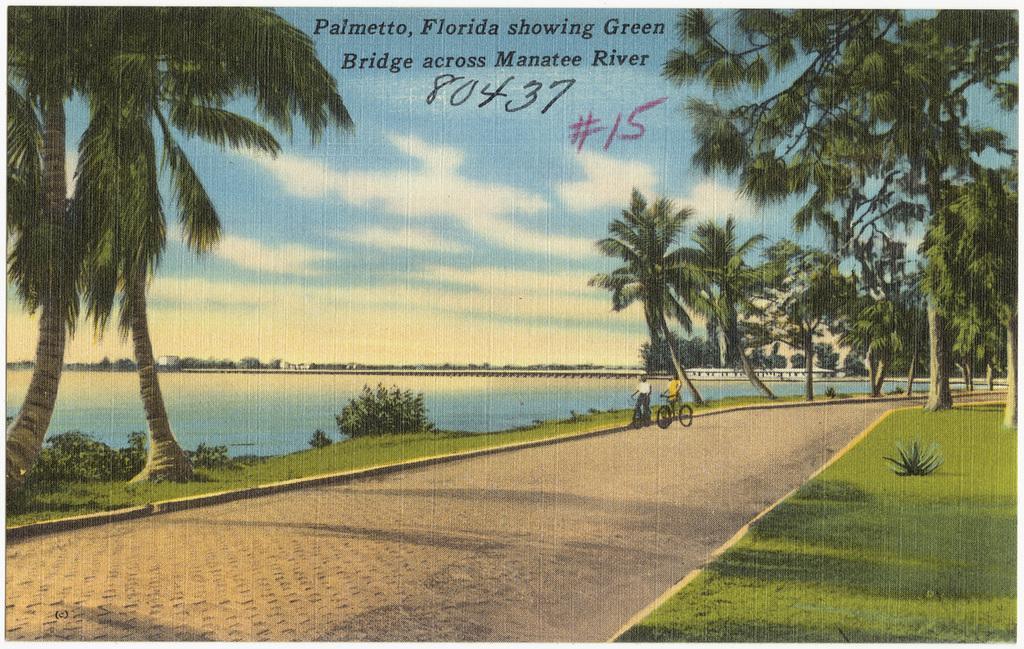How would you summarize this image in a sentence or two? In the picture we can see a photograph of a path with two people are standing with bicycles and besides it, we can see a grass surface and on it we can see trees and beside it, we can see water and far away from it we can see trees, sky with clouds. 